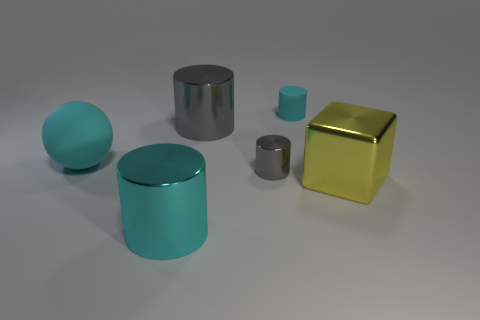There is a small thing that is made of the same material as the large gray cylinder; what is its color?
Offer a terse response. Gray. Are there fewer large rubber cylinders than large yellow blocks?
Provide a short and direct response. Yes. What number of green things are small metal cylinders or shiny blocks?
Provide a succinct answer. 0. How many cylinders are behind the large gray shiny cylinder and in front of the tiny cyan cylinder?
Make the answer very short. 0. Is the tiny gray thing made of the same material as the yellow block?
Your response must be concise. Yes. There is a gray metallic object that is the same size as the cyan sphere; what is its shape?
Keep it short and to the point. Cylinder. Is the number of big cylinders greater than the number of large yellow objects?
Provide a short and direct response. Yes. The object that is in front of the sphere and behind the big yellow block is made of what material?
Your answer should be very brief. Metal. What number of other things are there of the same material as the yellow block
Ensure brevity in your answer.  3. How many tiny matte objects are the same color as the large ball?
Provide a succinct answer. 1. 